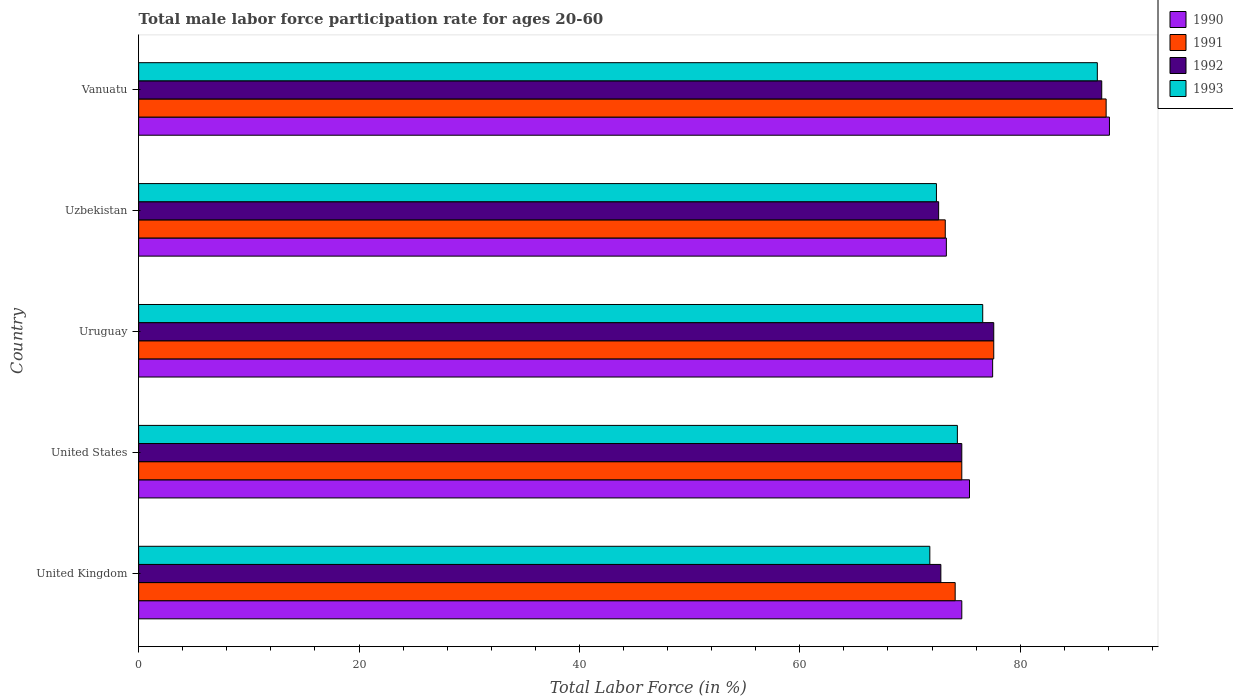How many different coloured bars are there?
Your answer should be very brief. 4. Are the number of bars per tick equal to the number of legend labels?
Keep it short and to the point. Yes. How many bars are there on the 2nd tick from the top?
Provide a short and direct response. 4. How many bars are there on the 3rd tick from the bottom?
Provide a short and direct response. 4. What is the label of the 3rd group of bars from the top?
Ensure brevity in your answer.  Uruguay. In how many cases, is the number of bars for a given country not equal to the number of legend labels?
Your response must be concise. 0. What is the male labor force participation rate in 1991 in Vanuatu?
Give a very brief answer. 87.8. Across all countries, what is the maximum male labor force participation rate in 1991?
Your response must be concise. 87.8. Across all countries, what is the minimum male labor force participation rate in 1993?
Provide a succinct answer. 71.8. In which country was the male labor force participation rate in 1993 maximum?
Provide a short and direct response. Vanuatu. In which country was the male labor force participation rate in 1992 minimum?
Provide a succinct answer. Uzbekistan. What is the total male labor force participation rate in 1990 in the graph?
Offer a terse response. 389. What is the difference between the male labor force participation rate in 1990 in United States and the male labor force participation rate in 1993 in Vanuatu?
Your response must be concise. -11.6. What is the average male labor force participation rate in 1992 per country?
Your answer should be very brief. 77.02. In how many countries, is the male labor force participation rate in 1992 greater than 52 %?
Make the answer very short. 5. What is the ratio of the male labor force participation rate in 1992 in Uruguay to that in Vanuatu?
Give a very brief answer. 0.89. Is the male labor force participation rate in 1990 in United States less than that in Uzbekistan?
Provide a short and direct response. No. Is the difference between the male labor force participation rate in 1993 in Uruguay and Vanuatu greater than the difference between the male labor force participation rate in 1991 in Uruguay and Vanuatu?
Your answer should be compact. No. What is the difference between the highest and the second highest male labor force participation rate in 1991?
Give a very brief answer. 10.2. What is the difference between the highest and the lowest male labor force participation rate in 1992?
Your answer should be very brief. 14.8. Is it the case that in every country, the sum of the male labor force participation rate in 1990 and male labor force participation rate in 1991 is greater than the sum of male labor force participation rate in 1992 and male labor force participation rate in 1993?
Make the answer very short. No. What does the 1st bar from the bottom in Uruguay represents?
Keep it short and to the point. 1990. Is it the case that in every country, the sum of the male labor force participation rate in 1991 and male labor force participation rate in 1992 is greater than the male labor force participation rate in 1993?
Make the answer very short. Yes. What is the difference between two consecutive major ticks on the X-axis?
Provide a short and direct response. 20. Does the graph contain any zero values?
Offer a terse response. No. Does the graph contain grids?
Keep it short and to the point. No. How many legend labels are there?
Your answer should be compact. 4. What is the title of the graph?
Give a very brief answer. Total male labor force participation rate for ages 20-60. Does "2007" appear as one of the legend labels in the graph?
Offer a very short reply. No. What is the Total Labor Force (in %) in 1990 in United Kingdom?
Provide a succinct answer. 74.7. What is the Total Labor Force (in %) in 1991 in United Kingdom?
Provide a short and direct response. 74.1. What is the Total Labor Force (in %) of 1992 in United Kingdom?
Provide a short and direct response. 72.8. What is the Total Labor Force (in %) of 1993 in United Kingdom?
Your answer should be very brief. 71.8. What is the Total Labor Force (in %) in 1990 in United States?
Give a very brief answer. 75.4. What is the Total Labor Force (in %) in 1991 in United States?
Your answer should be compact. 74.7. What is the Total Labor Force (in %) of 1992 in United States?
Your response must be concise. 74.7. What is the Total Labor Force (in %) of 1993 in United States?
Provide a succinct answer. 74.3. What is the Total Labor Force (in %) in 1990 in Uruguay?
Offer a terse response. 77.5. What is the Total Labor Force (in %) in 1991 in Uruguay?
Your answer should be very brief. 77.6. What is the Total Labor Force (in %) in 1992 in Uruguay?
Your response must be concise. 77.6. What is the Total Labor Force (in %) in 1993 in Uruguay?
Offer a very short reply. 76.6. What is the Total Labor Force (in %) of 1990 in Uzbekistan?
Give a very brief answer. 73.3. What is the Total Labor Force (in %) in 1991 in Uzbekistan?
Your answer should be very brief. 73.2. What is the Total Labor Force (in %) in 1992 in Uzbekistan?
Your response must be concise. 72.6. What is the Total Labor Force (in %) in 1993 in Uzbekistan?
Provide a succinct answer. 72.4. What is the Total Labor Force (in %) of 1990 in Vanuatu?
Your response must be concise. 88.1. What is the Total Labor Force (in %) in 1991 in Vanuatu?
Ensure brevity in your answer.  87.8. What is the Total Labor Force (in %) in 1992 in Vanuatu?
Your response must be concise. 87.4. What is the Total Labor Force (in %) of 1993 in Vanuatu?
Your answer should be very brief. 87. Across all countries, what is the maximum Total Labor Force (in %) of 1990?
Offer a very short reply. 88.1. Across all countries, what is the maximum Total Labor Force (in %) in 1991?
Ensure brevity in your answer.  87.8. Across all countries, what is the maximum Total Labor Force (in %) of 1992?
Give a very brief answer. 87.4. Across all countries, what is the minimum Total Labor Force (in %) in 1990?
Provide a short and direct response. 73.3. Across all countries, what is the minimum Total Labor Force (in %) of 1991?
Offer a very short reply. 73.2. Across all countries, what is the minimum Total Labor Force (in %) in 1992?
Ensure brevity in your answer.  72.6. Across all countries, what is the minimum Total Labor Force (in %) in 1993?
Give a very brief answer. 71.8. What is the total Total Labor Force (in %) in 1990 in the graph?
Make the answer very short. 389. What is the total Total Labor Force (in %) of 1991 in the graph?
Your answer should be compact. 387.4. What is the total Total Labor Force (in %) of 1992 in the graph?
Your answer should be compact. 385.1. What is the total Total Labor Force (in %) of 1993 in the graph?
Ensure brevity in your answer.  382.1. What is the difference between the Total Labor Force (in %) of 1990 in United Kingdom and that in United States?
Keep it short and to the point. -0.7. What is the difference between the Total Labor Force (in %) in 1992 in United Kingdom and that in United States?
Your answer should be compact. -1.9. What is the difference between the Total Labor Force (in %) of 1990 in United Kingdom and that in Uruguay?
Ensure brevity in your answer.  -2.8. What is the difference between the Total Labor Force (in %) of 1991 in United Kingdom and that in Uzbekistan?
Offer a terse response. 0.9. What is the difference between the Total Labor Force (in %) in 1992 in United Kingdom and that in Uzbekistan?
Offer a terse response. 0.2. What is the difference between the Total Labor Force (in %) in 1990 in United Kingdom and that in Vanuatu?
Provide a short and direct response. -13.4. What is the difference between the Total Labor Force (in %) of 1991 in United Kingdom and that in Vanuatu?
Give a very brief answer. -13.7. What is the difference between the Total Labor Force (in %) of 1992 in United Kingdom and that in Vanuatu?
Your answer should be very brief. -14.6. What is the difference between the Total Labor Force (in %) in 1993 in United Kingdom and that in Vanuatu?
Your response must be concise. -15.2. What is the difference between the Total Labor Force (in %) of 1992 in United States and that in Uruguay?
Offer a terse response. -2.9. What is the difference between the Total Labor Force (in %) of 1993 in United States and that in Uruguay?
Give a very brief answer. -2.3. What is the difference between the Total Labor Force (in %) of 1991 in United States and that in Uzbekistan?
Your answer should be compact. 1.5. What is the difference between the Total Labor Force (in %) in 1993 in United States and that in Uzbekistan?
Give a very brief answer. 1.9. What is the difference between the Total Labor Force (in %) in 1991 in United States and that in Vanuatu?
Give a very brief answer. -13.1. What is the difference between the Total Labor Force (in %) in 1993 in United States and that in Vanuatu?
Keep it short and to the point. -12.7. What is the difference between the Total Labor Force (in %) in 1990 in Uruguay and that in Uzbekistan?
Offer a terse response. 4.2. What is the difference between the Total Labor Force (in %) in 1992 in Uruguay and that in Uzbekistan?
Keep it short and to the point. 5. What is the difference between the Total Labor Force (in %) of 1993 in Uruguay and that in Uzbekistan?
Make the answer very short. 4.2. What is the difference between the Total Labor Force (in %) of 1990 in Uruguay and that in Vanuatu?
Your answer should be compact. -10.6. What is the difference between the Total Labor Force (in %) of 1991 in Uruguay and that in Vanuatu?
Make the answer very short. -10.2. What is the difference between the Total Labor Force (in %) of 1990 in Uzbekistan and that in Vanuatu?
Offer a very short reply. -14.8. What is the difference between the Total Labor Force (in %) in 1991 in Uzbekistan and that in Vanuatu?
Your answer should be compact. -14.6. What is the difference between the Total Labor Force (in %) of 1992 in Uzbekistan and that in Vanuatu?
Provide a short and direct response. -14.8. What is the difference between the Total Labor Force (in %) of 1993 in Uzbekistan and that in Vanuatu?
Offer a very short reply. -14.6. What is the difference between the Total Labor Force (in %) of 1990 in United Kingdom and the Total Labor Force (in %) of 1993 in United States?
Your answer should be compact. 0.4. What is the difference between the Total Labor Force (in %) in 1991 in United Kingdom and the Total Labor Force (in %) in 1992 in United States?
Offer a terse response. -0.6. What is the difference between the Total Labor Force (in %) in 1991 in United Kingdom and the Total Labor Force (in %) in 1993 in United States?
Give a very brief answer. -0.2. What is the difference between the Total Labor Force (in %) in 1992 in United Kingdom and the Total Labor Force (in %) in 1993 in United States?
Offer a very short reply. -1.5. What is the difference between the Total Labor Force (in %) of 1990 in United Kingdom and the Total Labor Force (in %) of 1991 in Uruguay?
Keep it short and to the point. -2.9. What is the difference between the Total Labor Force (in %) in 1991 in United Kingdom and the Total Labor Force (in %) in 1993 in Uruguay?
Make the answer very short. -2.5. What is the difference between the Total Labor Force (in %) of 1992 in United Kingdom and the Total Labor Force (in %) of 1993 in Uruguay?
Provide a succinct answer. -3.8. What is the difference between the Total Labor Force (in %) in 1990 in United Kingdom and the Total Labor Force (in %) in 1992 in Uzbekistan?
Make the answer very short. 2.1. What is the difference between the Total Labor Force (in %) in 1990 in United Kingdom and the Total Labor Force (in %) in 1993 in Uzbekistan?
Your answer should be compact. 2.3. What is the difference between the Total Labor Force (in %) in 1991 in United Kingdom and the Total Labor Force (in %) in 1992 in Uzbekistan?
Your answer should be compact. 1.5. What is the difference between the Total Labor Force (in %) of 1990 in United Kingdom and the Total Labor Force (in %) of 1992 in Vanuatu?
Provide a short and direct response. -12.7. What is the difference between the Total Labor Force (in %) of 1991 in United Kingdom and the Total Labor Force (in %) of 1993 in Vanuatu?
Your answer should be very brief. -12.9. What is the difference between the Total Labor Force (in %) of 1992 in United Kingdom and the Total Labor Force (in %) of 1993 in Vanuatu?
Provide a short and direct response. -14.2. What is the difference between the Total Labor Force (in %) of 1990 in United States and the Total Labor Force (in %) of 1991 in Uruguay?
Offer a very short reply. -2.2. What is the difference between the Total Labor Force (in %) in 1991 in United States and the Total Labor Force (in %) in 1992 in Uruguay?
Offer a terse response. -2.9. What is the difference between the Total Labor Force (in %) in 1992 in United States and the Total Labor Force (in %) in 1993 in Uruguay?
Offer a very short reply. -1.9. What is the difference between the Total Labor Force (in %) in 1990 in United States and the Total Labor Force (in %) in 1991 in Uzbekistan?
Give a very brief answer. 2.2. What is the difference between the Total Labor Force (in %) of 1990 in United States and the Total Labor Force (in %) of 1992 in Uzbekistan?
Ensure brevity in your answer.  2.8. What is the difference between the Total Labor Force (in %) of 1990 in United States and the Total Labor Force (in %) of 1993 in Uzbekistan?
Your response must be concise. 3. What is the difference between the Total Labor Force (in %) of 1991 in United States and the Total Labor Force (in %) of 1992 in Uzbekistan?
Your answer should be very brief. 2.1. What is the difference between the Total Labor Force (in %) in 1992 in United States and the Total Labor Force (in %) in 1993 in Uzbekistan?
Your answer should be very brief. 2.3. What is the difference between the Total Labor Force (in %) of 1990 in United States and the Total Labor Force (in %) of 1993 in Vanuatu?
Make the answer very short. -11.6. What is the difference between the Total Labor Force (in %) of 1991 in United States and the Total Labor Force (in %) of 1993 in Vanuatu?
Provide a short and direct response. -12.3. What is the difference between the Total Labor Force (in %) in 1990 in Uruguay and the Total Labor Force (in %) in 1991 in Uzbekistan?
Provide a short and direct response. 4.3. What is the difference between the Total Labor Force (in %) in 1991 in Uruguay and the Total Labor Force (in %) in 1992 in Uzbekistan?
Make the answer very short. 5. What is the difference between the Total Labor Force (in %) in 1992 in Uruguay and the Total Labor Force (in %) in 1993 in Uzbekistan?
Your response must be concise. 5.2. What is the difference between the Total Labor Force (in %) of 1990 in Uruguay and the Total Labor Force (in %) of 1992 in Vanuatu?
Your response must be concise. -9.9. What is the difference between the Total Labor Force (in %) in 1990 in Uruguay and the Total Labor Force (in %) in 1993 in Vanuatu?
Keep it short and to the point. -9.5. What is the difference between the Total Labor Force (in %) in 1991 in Uruguay and the Total Labor Force (in %) in 1992 in Vanuatu?
Give a very brief answer. -9.8. What is the difference between the Total Labor Force (in %) in 1992 in Uruguay and the Total Labor Force (in %) in 1993 in Vanuatu?
Ensure brevity in your answer.  -9.4. What is the difference between the Total Labor Force (in %) in 1990 in Uzbekistan and the Total Labor Force (in %) in 1991 in Vanuatu?
Offer a terse response. -14.5. What is the difference between the Total Labor Force (in %) of 1990 in Uzbekistan and the Total Labor Force (in %) of 1992 in Vanuatu?
Give a very brief answer. -14.1. What is the difference between the Total Labor Force (in %) of 1990 in Uzbekistan and the Total Labor Force (in %) of 1993 in Vanuatu?
Keep it short and to the point. -13.7. What is the difference between the Total Labor Force (in %) of 1992 in Uzbekistan and the Total Labor Force (in %) of 1993 in Vanuatu?
Provide a succinct answer. -14.4. What is the average Total Labor Force (in %) in 1990 per country?
Offer a terse response. 77.8. What is the average Total Labor Force (in %) of 1991 per country?
Ensure brevity in your answer.  77.48. What is the average Total Labor Force (in %) in 1992 per country?
Your answer should be very brief. 77.02. What is the average Total Labor Force (in %) of 1993 per country?
Provide a succinct answer. 76.42. What is the difference between the Total Labor Force (in %) in 1990 and Total Labor Force (in %) in 1991 in United Kingdom?
Offer a terse response. 0.6. What is the difference between the Total Labor Force (in %) of 1990 and Total Labor Force (in %) of 1992 in United Kingdom?
Ensure brevity in your answer.  1.9. What is the difference between the Total Labor Force (in %) in 1990 and Total Labor Force (in %) in 1993 in United Kingdom?
Your answer should be compact. 2.9. What is the difference between the Total Labor Force (in %) in 1991 and Total Labor Force (in %) in 1993 in United Kingdom?
Ensure brevity in your answer.  2.3. What is the difference between the Total Labor Force (in %) in 1992 and Total Labor Force (in %) in 1993 in United Kingdom?
Offer a terse response. 1. What is the difference between the Total Labor Force (in %) of 1990 and Total Labor Force (in %) of 1991 in United States?
Keep it short and to the point. 0.7. What is the difference between the Total Labor Force (in %) of 1990 and Total Labor Force (in %) of 1992 in United States?
Provide a short and direct response. 0.7. What is the difference between the Total Labor Force (in %) of 1990 and Total Labor Force (in %) of 1993 in United States?
Provide a short and direct response. 1.1. What is the difference between the Total Labor Force (in %) of 1990 and Total Labor Force (in %) of 1991 in Uruguay?
Provide a short and direct response. -0.1. What is the difference between the Total Labor Force (in %) of 1990 and Total Labor Force (in %) of 1991 in Uzbekistan?
Your answer should be compact. 0.1. What is the difference between the Total Labor Force (in %) of 1990 and Total Labor Force (in %) of 1993 in Uzbekistan?
Your response must be concise. 0.9. What is the difference between the Total Labor Force (in %) of 1990 and Total Labor Force (in %) of 1993 in Vanuatu?
Make the answer very short. 1.1. What is the difference between the Total Labor Force (in %) of 1991 and Total Labor Force (in %) of 1992 in Vanuatu?
Provide a short and direct response. 0.4. What is the difference between the Total Labor Force (in %) in 1992 and Total Labor Force (in %) in 1993 in Vanuatu?
Give a very brief answer. 0.4. What is the ratio of the Total Labor Force (in %) in 1990 in United Kingdom to that in United States?
Provide a succinct answer. 0.99. What is the ratio of the Total Labor Force (in %) of 1991 in United Kingdom to that in United States?
Provide a succinct answer. 0.99. What is the ratio of the Total Labor Force (in %) of 1992 in United Kingdom to that in United States?
Provide a short and direct response. 0.97. What is the ratio of the Total Labor Force (in %) in 1993 in United Kingdom to that in United States?
Offer a terse response. 0.97. What is the ratio of the Total Labor Force (in %) of 1990 in United Kingdom to that in Uruguay?
Give a very brief answer. 0.96. What is the ratio of the Total Labor Force (in %) in 1991 in United Kingdom to that in Uruguay?
Offer a terse response. 0.95. What is the ratio of the Total Labor Force (in %) in 1992 in United Kingdom to that in Uruguay?
Your answer should be very brief. 0.94. What is the ratio of the Total Labor Force (in %) in 1993 in United Kingdom to that in Uruguay?
Provide a short and direct response. 0.94. What is the ratio of the Total Labor Force (in %) of 1990 in United Kingdom to that in Uzbekistan?
Offer a terse response. 1.02. What is the ratio of the Total Labor Force (in %) of 1991 in United Kingdom to that in Uzbekistan?
Provide a short and direct response. 1.01. What is the ratio of the Total Labor Force (in %) in 1992 in United Kingdom to that in Uzbekistan?
Provide a short and direct response. 1. What is the ratio of the Total Labor Force (in %) of 1990 in United Kingdom to that in Vanuatu?
Make the answer very short. 0.85. What is the ratio of the Total Labor Force (in %) of 1991 in United Kingdom to that in Vanuatu?
Your response must be concise. 0.84. What is the ratio of the Total Labor Force (in %) of 1992 in United Kingdom to that in Vanuatu?
Your response must be concise. 0.83. What is the ratio of the Total Labor Force (in %) of 1993 in United Kingdom to that in Vanuatu?
Provide a succinct answer. 0.83. What is the ratio of the Total Labor Force (in %) in 1990 in United States to that in Uruguay?
Give a very brief answer. 0.97. What is the ratio of the Total Labor Force (in %) of 1991 in United States to that in Uruguay?
Your answer should be very brief. 0.96. What is the ratio of the Total Labor Force (in %) in 1992 in United States to that in Uruguay?
Keep it short and to the point. 0.96. What is the ratio of the Total Labor Force (in %) in 1990 in United States to that in Uzbekistan?
Your answer should be compact. 1.03. What is the ratio of the Total Labor Force (in %) of 1991 in United States to that in Uzbekistan?
Your response must be concise. 1.02. What is the ratio of the Total Labor Force (in %) of 1992 in United States to that in Uzbekistan?
Your answer should be compact. 1.03. What is the ratio of the Total Labor Force (in %) in 1993 in United States to that in Uzbekistan?
Ensure brevity in your answer.  1.03. What is the ratio of the Total Labor Force (in %) in 1990 in United States to that in Vanuatu?
Make the answer very short. 0.86. What is the ratio of the Total Labor Force (in %) of 1991 in United States to that in Vanuatu?
Keep it short and to the point. 0.85. What is the ratio of the Total Labor Force (in %) in 1992 in United States to that in Vanuatu?
Offer a very short reply. 0.85. What is the ratio of the Total Labor Force (in %) of 1993 in United States to that in Vanuatu?
Provide a succinct answer. 0.85. What is the ratio of the Total Labor Force (in %) of 1990 in Uruguay to that in Uzbekistan?
Your response must be concise. 1.06. What is the ratio of the Total Labor Force (in %) of 1991 in Uruguay to that in Uzbekistan?
Your response must be concise. 1.06. What is the ratio of the Total Labor Force (in %) of 1992 in Uruguay to that in Uzbekistan?
Keep it short and to the point. 1.07. What is the ratio of the Total Labor Force (in %) in 1993 in Uruguay to that in Uzbekistan?
Ensure brevity in your answer.  1.06. What is the ratio of the Total Labor Force (in %) of 1990 in Uruguay to that in Vanuatu?
Ensure brevity in your answer.  0.88. What is the ratio of the Total Labor Force (in %) of 1991 in Uruguay to that in Vanuatu?
Make the answer very short. 0.88. What is the ratio of the Total Labor Force (in %) in 1992 in Uruguay to that in Vanuatu?
Give a very brief answer. 0.89. What is the ratio of the Total Labor Force (in %) of 1993 in Uruguay to that in Vanuatu?
Ensure brevity in your answer.  0.88. What is the ratio of the Total Labor Force (in %) of 1990 in Uzbekistan to that in Vanuatu?
Keep it short and to the point. 0.83. What is the ratio of the Total Labor Force (in %) in 1991 in Uzbekistan to that in Vanuatu?
Offer a very short reply. 0.83. What is the ratio of the Total Labor Force (in %) of 1992 in Uzbekistan to that in Vanuatu?
Your answer should be compact. 0.83. What is the ratio of the Total Labor Force (in %) of 1993 in Uzbekistan to that in Vanuatu?
Give a very brief answer. 0.83. What is the difference between the highest and the second highest Total Labor Force (in %) in 1993?
Provide a short and direct response. 10.4. What is the difference between the highest and the lowest Total Labor Force (in %) in 1991?
Your response must be concise. 14.6. What is the difference between the highest and the lowest Total Labor Force (in %) of 1993?
Make the answer very short. 15.2. 